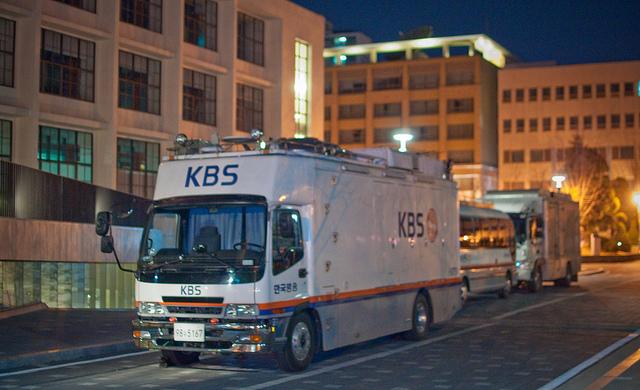How many vehicles can be seen?
Answer briefly. 3. What is the middle letter in the three letters on the front of the van?
Quick response, please. B. What time is it?
Answer briefly. Night. Is the truck pulling something?
Short answer required. No. 